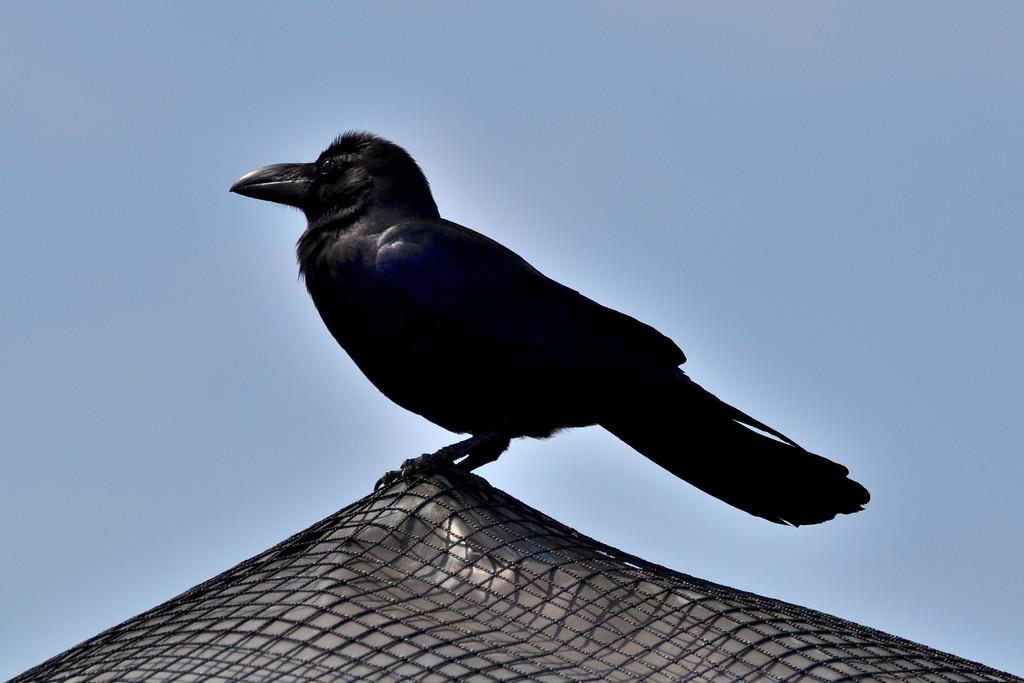What type of animal can be seen in the picture? There is a bird in the picture. What is the bird standing on? The bird is standing on a stainless steel object. What is present on the stainless steel object? There is a net on the stainless steel object. What can be seen in the sky in the picture? There are clouds in the sky. What type of scent can be detected from the bird in the image? There is no information about the scent of the bird in the image, and therefore it cannot be determined. 